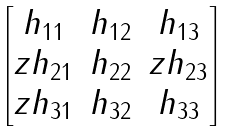<formula> <loc_0><loc_0><loc_500><loc_500>\begin{bmatrix} h _ { 1 1 } & h _ { 1 2 } & h _ { 1 3 } \\ z h _ { 2 1 } & h _ { 2 2 } & z h _ { 2 3 } \\ z h _ { 3 1 } & h _ { 3 2 } & h _ { 3 3 } \end{bmatrix}</formula> 